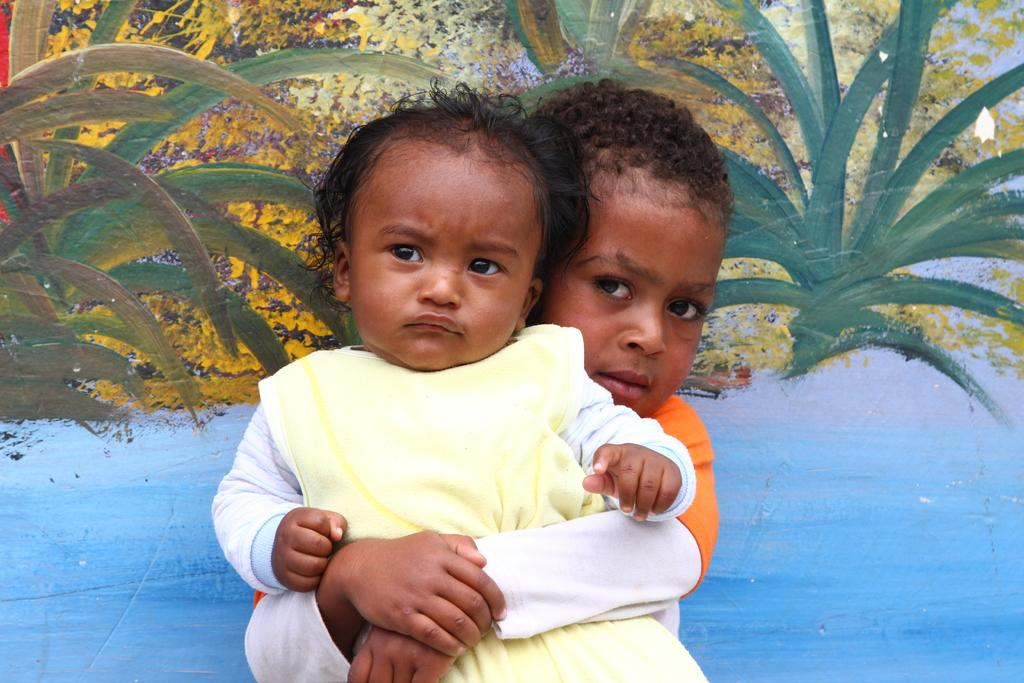How many children are present in the image? There are two children in the image. Can you describe the background of the image? There is a wall in the background of the image. What type of guide is present in the image to help the pigs find their way to the nation? There are no pigs, guides, or nations present in the image; it only features two children and a wall in the background. 